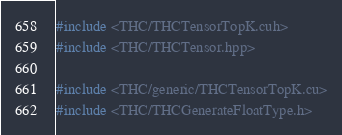<code> <loc_0><loc_0><loc_500><loc_500><_Cuda_>#include <THC/THCTensorTopK.cuh>
#include <THC/THCTensor.hpp>

#include <THC/generic/THCTensorTopK.cu>
#include <THC/THCGenerateFloatType.h>
</code> 